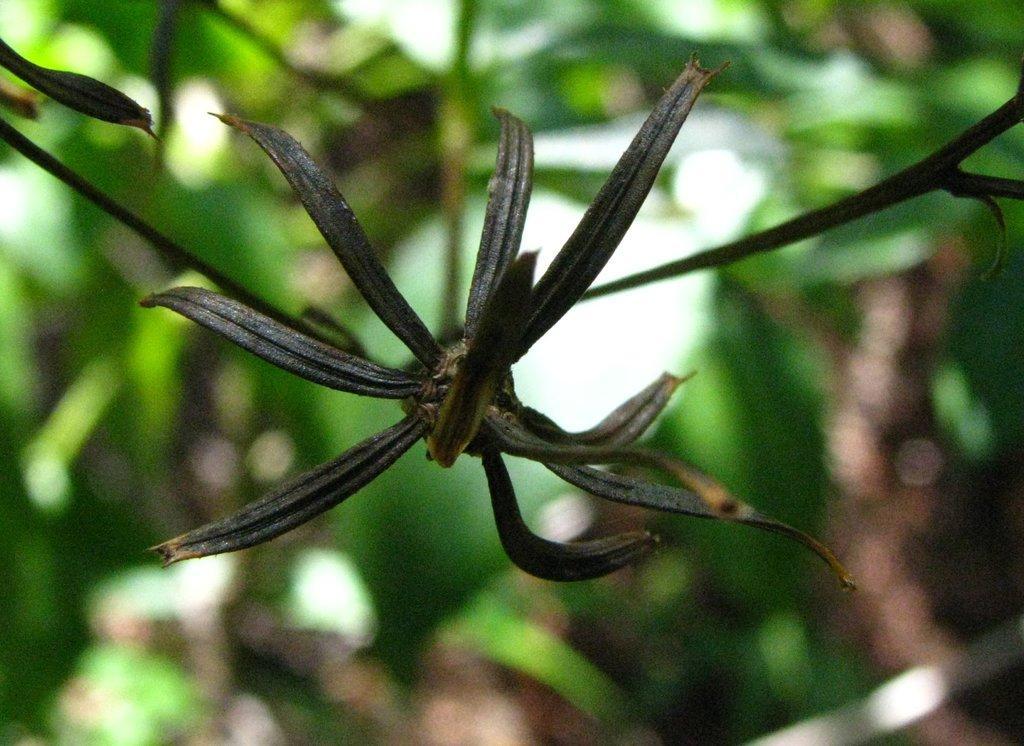How would you summarize this image in a sentence or two? In this picture I can see a plant and looks like a tree in the background. 